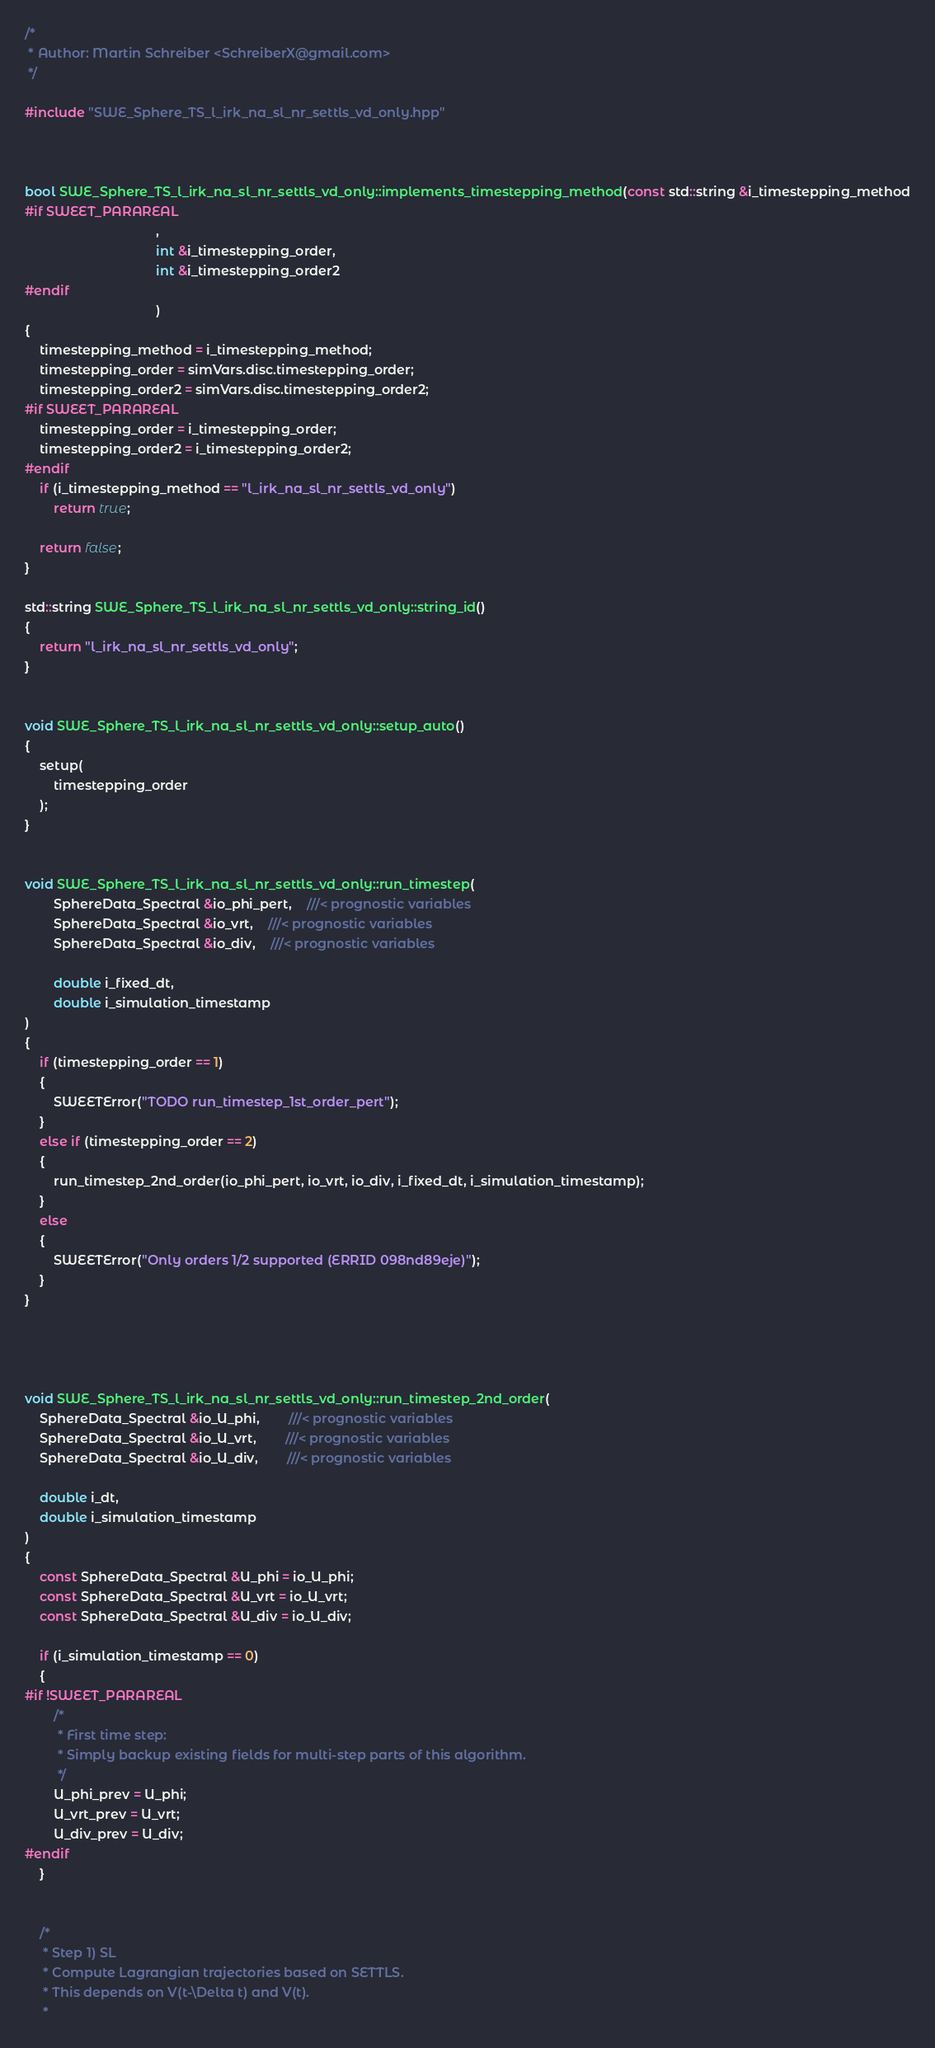Convert code to text. <code><loc_0><loc_0><loc_500><loc_500><_C++_>/*
 * Author: Martin Schreiber <SchreiberX@gmail.com>
 */

#include "SWE_Sphere_TS_l_irk_na_sl_nr_settls_vd_only.hpp"



bool SWE_Sphere_TS_l_irk_na_sl_nr_settls_vd_only::implements_timestepping_method(const std::string &i_timestepping_method
#if SWEET_PARAREAL
									,
									int &i_timestepping_order,
									int &i_timestepping_order2
#endif
									)
{
	timestepping_method = i_timestepping_method;
	timestepping_order = simVars.disc.timestepping_order;
	timestepping_order2 = simVars.disc.timestepping_order2;
#if SWEET_PARAREAL
	timestepping_order = i_timestepping_order;
	timestepping_order2 = i_timestepping_order2;
#endif
	if (i_timestepping_method == "l_irk_na_sl_nr_settls_vd_only")
		return true;

	return false;
}

std::string SWE_Sphere_TS_l_irk_na_sl_nr_settls_vd_only::string_id()
{
	return "l_irk_na_sl_nr_settls_vd_only";
}


void SWE_Sphere_TS_l_irk_na_sl_nr_settls_vd_only::setup_auto()
{
	setup(
		timestepping_order
	);
}


void SWE_Sphere_TS_l_irk_na_sl_nr_settls_vd_only::run_timestep(
		SphereData_Spectral &io_phi_pert,	///< prognostic variables
		SphereData_Spectral &io_vrt,	///< prognostic variables
		SphereData_Spectral &io_div,	///< prognostic variables

		double i_fixed_dt,
		double i_simulation_timestamp
)
{
	if (timestepping_order == 1)
	{
		SWEETError("TODO run_timestep_1st_order_pert");
	}
	else if (timestepping_order == 2)
	{
		run_timestep_2nd_order(io_phi_pert, io_vrt, io_div, i_fixed_dt, i_simulation_timestamp);
	}
	else
	{
		SWEETError("Only orders 1/2 supported (ERRID 098nd89eje)");
	}
}




void SWE_Sphere_TS_l_irk_na_sl_nr_settls_vd_only::run_timestep_2nd_order(
	SphereData_Spectral &io_U_phi,		///< prognostic variables
	SphereData_Spectral &io_U_vrt,		///< prognostic variables
	SphereData_Spectral &io_U_div,		///< prognostic variables

	double i_dt,		
	double i_simulation_timestamp
)
{
	const SphereData_Spectral &U_phi = io_U_phi;
	const SphereData_Spectral &U_vrt = io_U_vrt;
	const SphereData_Spectral &U_div = io_U_div;

	if (i_simulation_timestamp == 0)
	{
#if !SWEET_PARAREAL
		/*
		 * First time step:
		 * Simply backup existing fields for multi-step parts of this algorithm.
		 */
		U_phi_prev = U_phi;
		U_vrt_prev = U_vrt;
		U_div_prev = U_div;
#endif
	}


	/*
	 * Step 1) SL
	 * Compute Lagrangian trajectories based on SETTLS.
	 * This depends on V(t-\Delta t) and V(t).
	 *</code> 